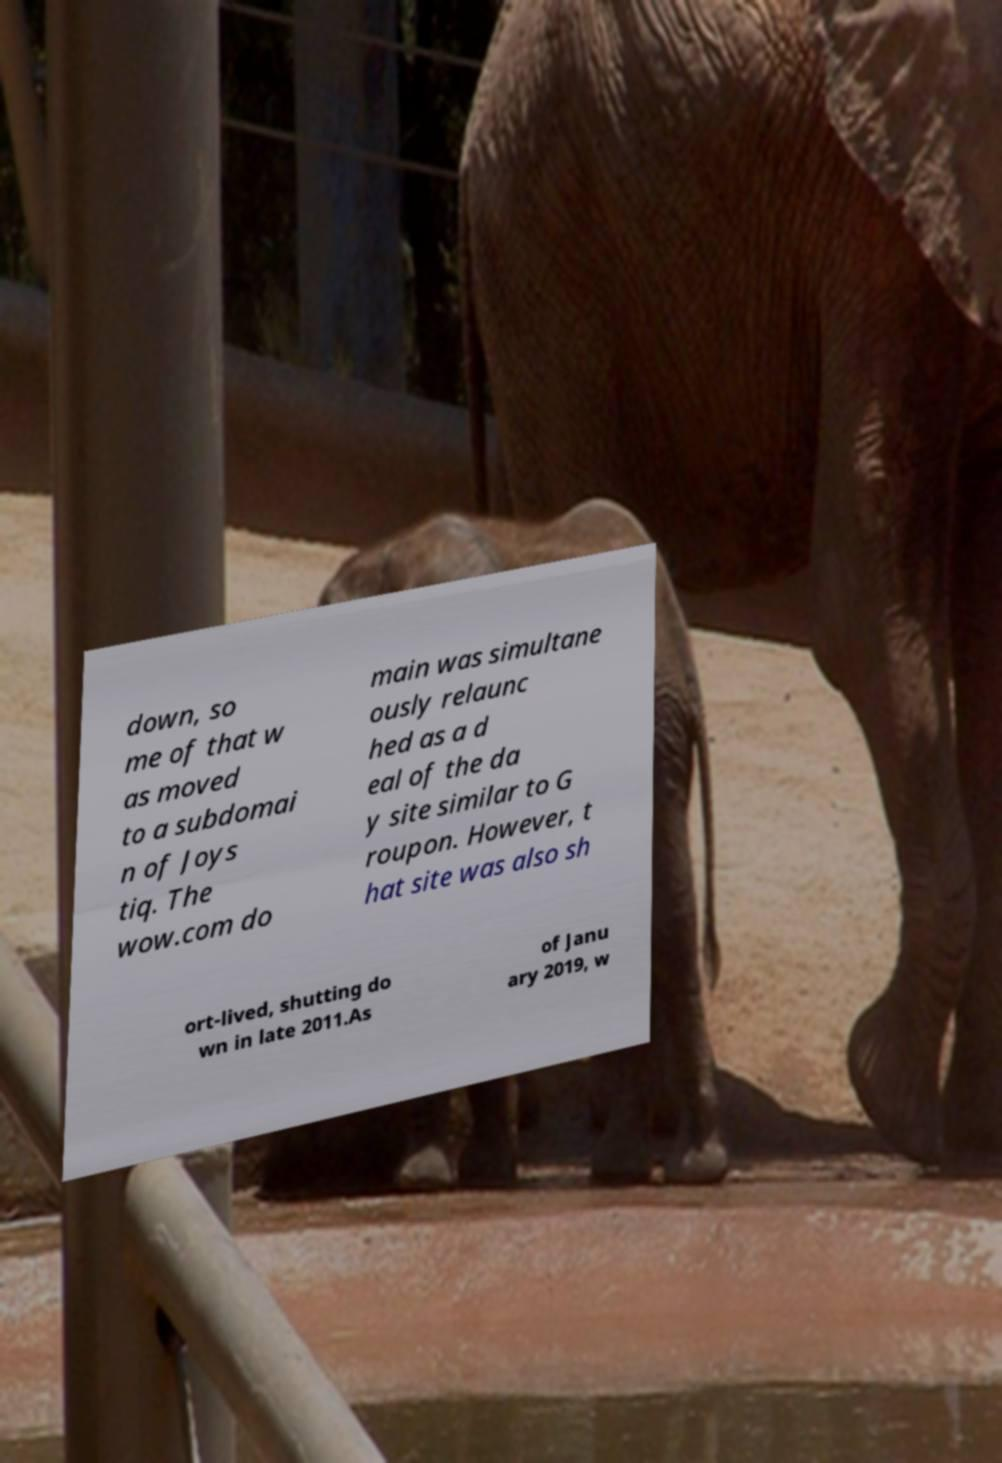What messages or text are displayed in this image? I need them in a readable, typed format. down, so me of that w as moved to a subdomai n of Joys tiq. The wow.com do main was simultane ously relaunc hed as a d eal of the da y site similar to G roupon. However, t hat site was also sh ort-lived, shutting do wn in late 2011.As of Janu ary 2019, w 